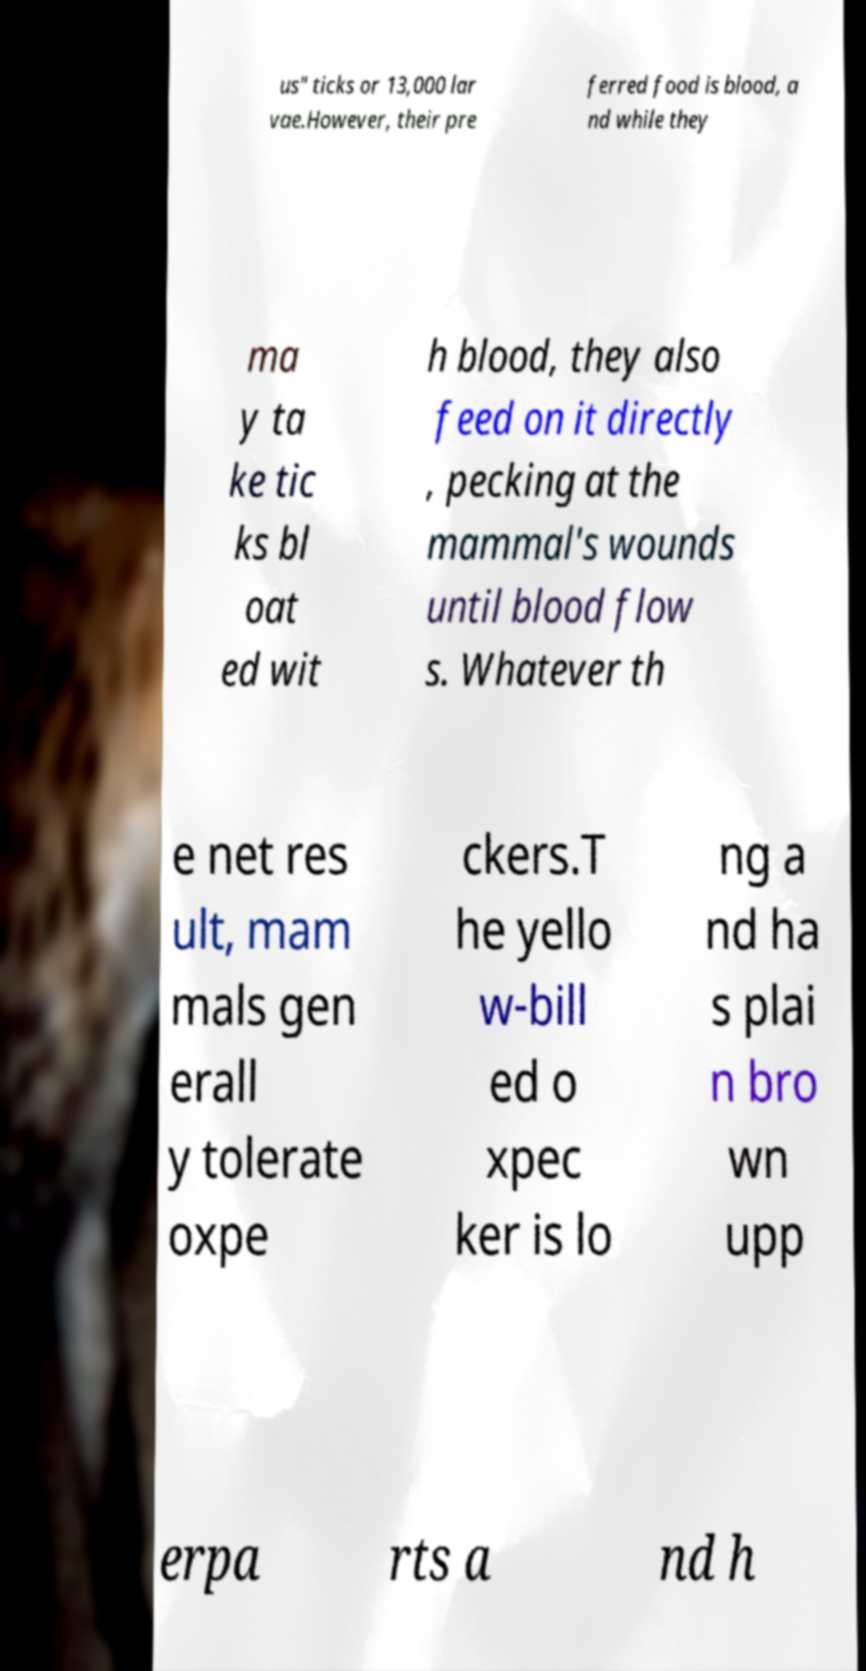Can you accurately transcribe the text from the provided image for me? us" ticks or 13,000 lar vae.However, their pre ferred food is blood, a nd while they ma y ta ke tic ks bl oat ed wit h blood, they also feed on it directly , pecking at the mammal's wounds until blood flow s. Whatever th e net res ult, mam mals gen erall y tolerate oxpe ckers.T he yello w-bill ed o xpec ker is lo ng a nd ha s plai n bro wn upp erpa rts a nd h 